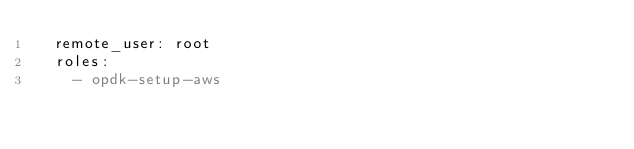Convert code to text. <code><loc_0><loc_0><loc_500><loc_500><_YAML_>  remote_user: root
  roles:
    - opdk-setup-aws</code> 